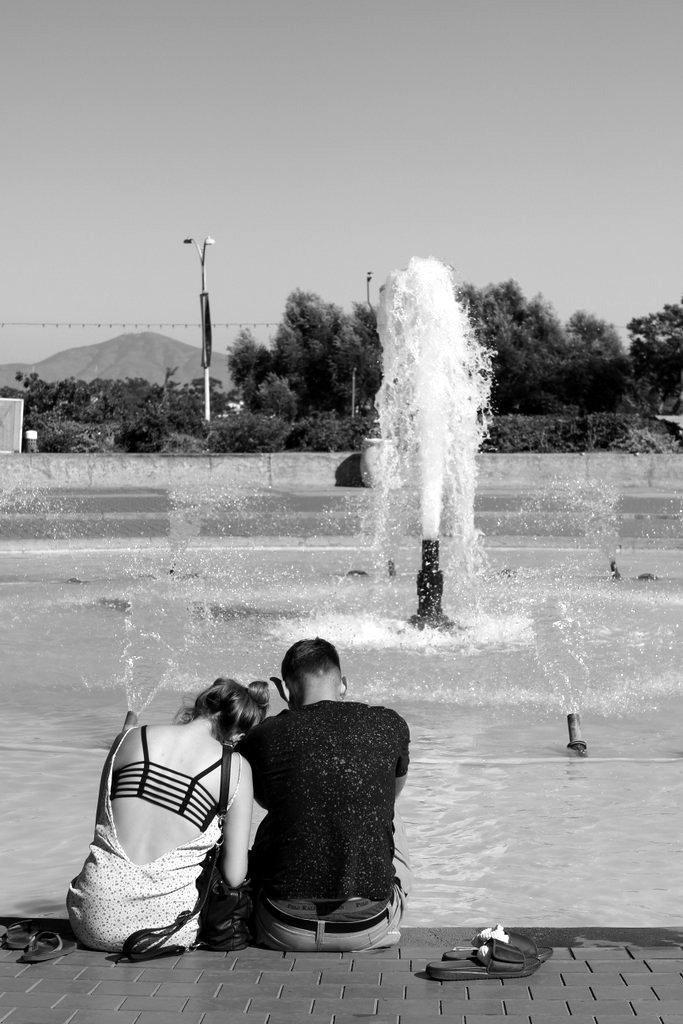Could you give a brief overview of what you see in this image? In the image I can see a lady and a guy who are sitting on the path and beside them there are footwear and also I can see a water fountain, trees, plants and a pole. 